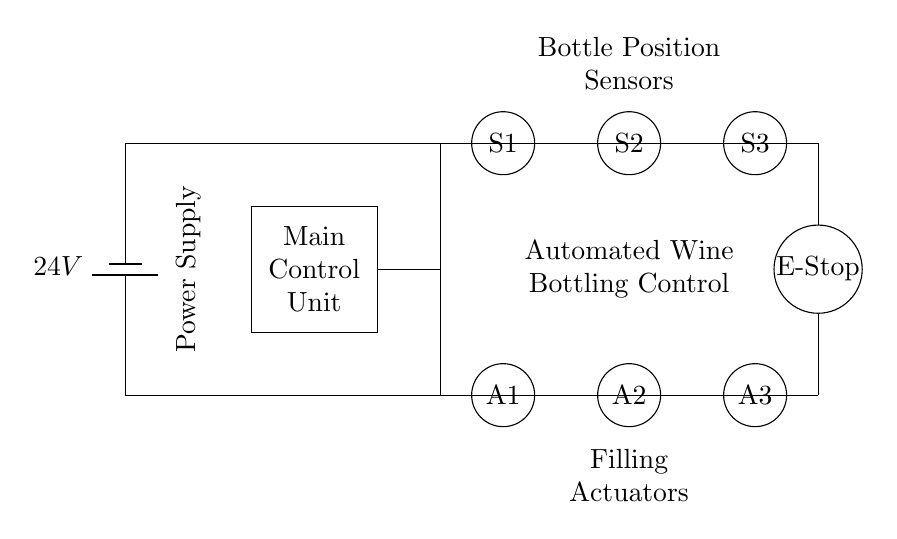What is the voltage of this circuit? The voltage is 24 volts, indicated by the battery symbol in the diagram, which shows that it provides power to the circuit.
Answer: 24 volts What is the function of S1, S2, and S3? S1, S2, and S3 are described as bottle position sensors; they detect the presence of bottles in different positions along the bottling line.
Answer: Bottle position sensors What do A1, A2, and A3 represent? A1, A2, and A3 are labeled as filling actuators; they are responsible for dispensing wine into the bottles during the bottling process.
Answer: Filling actuators How many sensors are present in this circuit? There are three sensors (S1, S2, S3) depicted in the diagram that are used to detect bottle positions.
Answer: Three What connects the main control unit to the sensors? The main control unit connects to the sensors via wires, shown as lines in the diagram, establishing a communication pathway for operation.
Answer: Wires Why is the E-stop important in this circuit? The emergency stop (E-stop) is crucial for safety; it allows for immediate cessation of operations in case of a malfunction or danger in the bottling process.
Answer: Safety mechanism What do the labels indicate about the function of this circuit? The labels indicate that the circuit's purpose is to automate the wine bottling process, integrating sensor feedback and actuator control for efficient operation.
Answer: Automated wine bottling control 